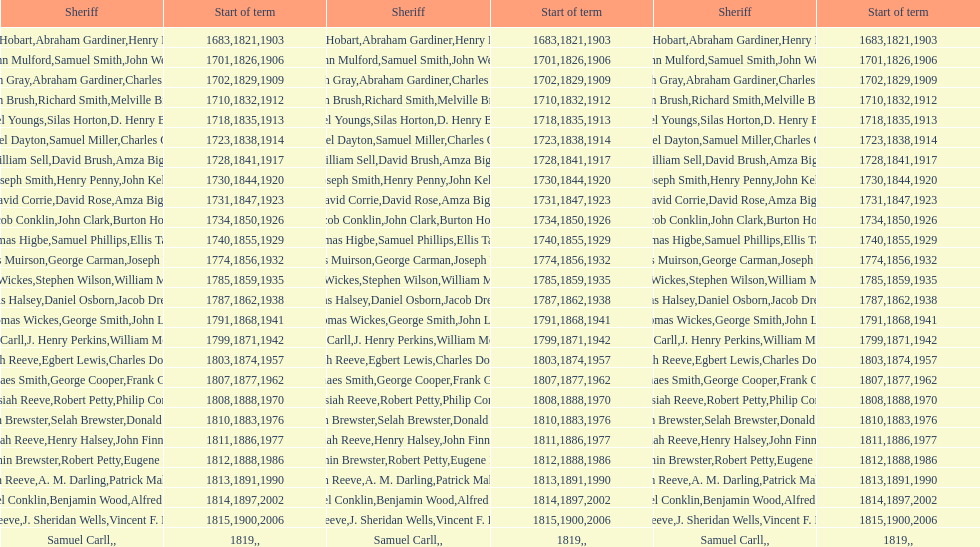What is the total number of sheriffs that were in office in suffolk county between 1903 and 1957? 17. 